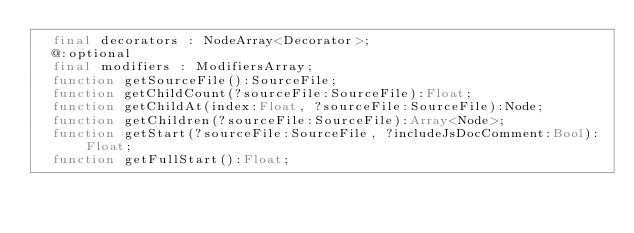<code> <loc_0><loc_0><loc_500><loc_500><_Haxe_>	final decorators : NodeArray<Decorator>;
	@:optional
	final modifiers : ModifiersArray;
	function getSourceFile():SourceFile;
	function getChildCount(?sourceFile:SourceFile):Float;
	function getChildAt(index:Float, ?sourceFile:SourceFile):Node;
	function getChildren(?sourceFile:SourceFile):Array<Node>;
	function getStart(?sourceFile:SourceFile, ?includeJsDocComment:Bool):Float;
	function getFullStart():Float;</code> 